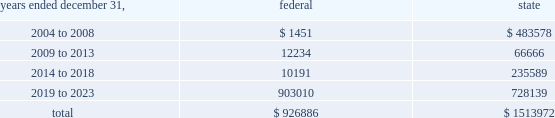American tower corporation and subsidiaries notes to consolidated financial statements 2014 ( continued ) basis step-up from corporate restructuring represents the tax effects of increasing the basis for tax purposes of certain of the company 2019s assets in conjunction with its spin-off from american radio systems corporation , its former parent company .
At december 31 , 2003 , the company had net federal and state operating loss carryforwards available to reduce future taxable income of approximately $ 0.9 billion and $ 1.5 billion , respectively .
If not utilized , the company 2019s net operating loss carryforwards expire as follows ( in thousands ) : .
Sfas no .
109 , 201caccounting for income taxes , 201d requires that companies record a valuation allowance when it is 201cmore likely than not that some portion or all of the deferred tax assets will not be realized . 201d at december 31 , 2003 , the company has provided a valuation allowance of approximately $ 156.7 million , primarily related to net state deferred tax assets , capital loss carryforwards and the lost tax benefit and costs associated with our tax refund claims .
The company has not provided a valuation allowance for the remaining net deferred tax assets , primarily its tax refund claims and federal net operating loss carryforwards , as management believes the company will be successful with its tax refund claims and have sufficient time to realize these federal net operating loss carryforwards during the twenty-year tax carryforward period .
The company intends to recover a portion of its deferred tax asset through its tax refund claims , related to certain federal net operating losses , filed during 2003 as part of a tax planning strategy implemented in 2002 .
The recoverability of its remaining net deferred tax asset has been assessed utilizing stable state ( no growth ) projections based on its current operations .
The projections show a significant decrease in depreciation and interest expense in the later years of the carryforward period as a result of a significant portion of its assets being fully depreciated during the first fifteen years of the carryforward period and debt repayments reducing interest expense .
Accordingly , the recoverability of the net deferred tax asset is not dependent on material improvements to operations , material asset sales or other non-routine transactions .
Based on its current outlook of future taxable income during the carryforward period , management believes that the net deferred tax asset will be realized .
The realization of the company 2019s deferred tax assets will be dependent upon its ability to generate approximately $ 1.0 billion in taxable income from january 1 , 2004 to december 31 , 2023 .
If the company is unable to generate sufficient taxable income in the future , or carry back losses as described above , it will be required to reduce its net deferred tax asset through a charge to income tax expense , which would result in a corresponding decrease in stockholders 2019 equity .
Depending on the resolution of the verestar bankruptcy proceedings described in note 2 , the company may be entitled to a worthless stock or bad debt deduction for its investment in verestar .
No income tax benefit has been provided for these potential deductions due to the uncertainty surrounding the bankruptcy proceedings .
13 .
Stockholders 2019 equity preferred stock as of december 31 , 2003 the company was authorized to issue up to 20.0 million shares of $ .01 par value preferred stock .
As of december 31 , 2003 and 2002 there were no preferred shares issued or outstanding. .
What portion of the federal operating loss carryforwards expires between 2004 and 2008? 
Computations: (1451 / 926886)
Answer: 0.00157. 